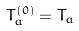<formula> <loc_0><loc_0><loc_500><loc_500>T _ { a } ^ { ( 0 ) } = T _ { a }</formula> 